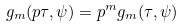<formula> <loc_0><loc_0><loc_500><loc_500>g _ { m } ( p \tau , \psi ) = p ^ { m } g _ { m } ( \tau , \psi ) \\</formula> 